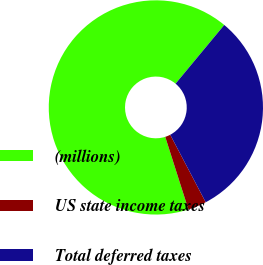Convert chart to OTSL. <chart><loc_0><loc_0><loc_500><loc_500><pie_chart><fcel>(millions)<fcel>US state income taxes<fcel>Total deferred taxes<nl><fcel>65.93%<fcel>2.79%<fcel>31.28%<nl></chart> 